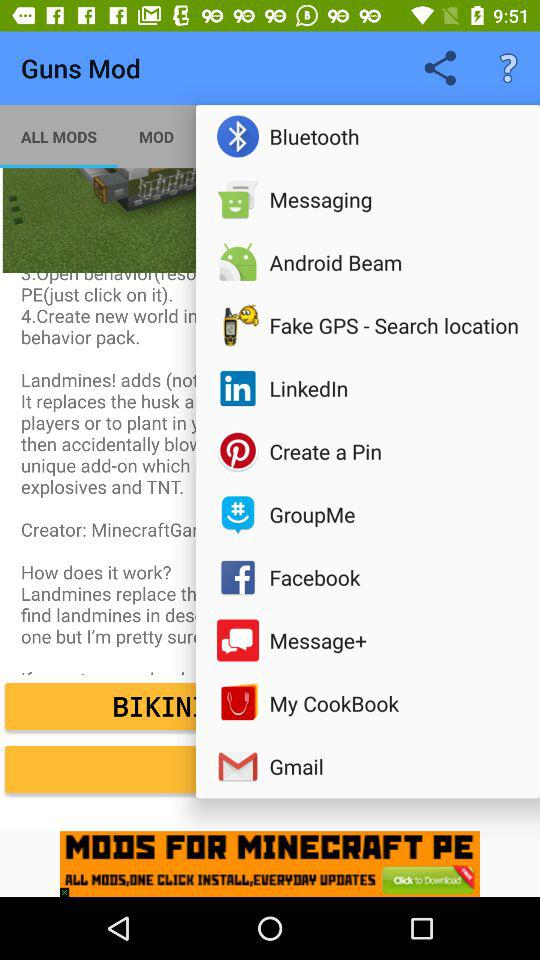Which option is selected in the drop-down menu?
When the provided information is insufficient, respond with <no answer>. <no answer> 